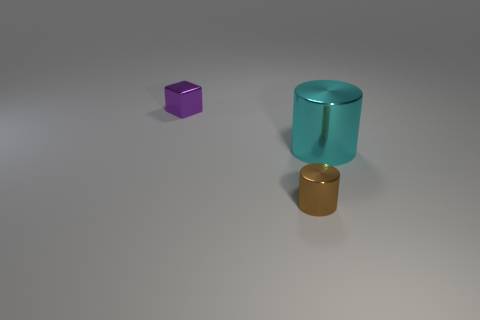Is the shape of the tiny thing that is to the right of the cube the same as  the big thing?
Offer a very short reply. Yes. What is the shape of the purple metal thing?
Your answer should be compact. Cube. How many large cyan things are the same material as the small purple thing?
Provide a succinct answer. 1. Do the small metallic cylinder and the small object behind the large object have the same color?
Keep it short and to the point. No. What number of large red rubber cubes are there?
Your answer should be compact. 0. Is there a tiny object that has the same color as the metallic block?
Your answer should be very brief. No. There is a thing in front of the cylinder on the right side of the small metallic thing that is in front of the small purple object; what is its color?
Keep it short and to the point. Brown. Is the material of the small brown object the same as the small object behind the small brown shiny cylinder?
Ensure brevity in your answer.  Yes. What is the material of the purple block?
Give a very brief answer. Metal. What number of other things are there of the same material as the small purple block
Offer a terse response. 2. 